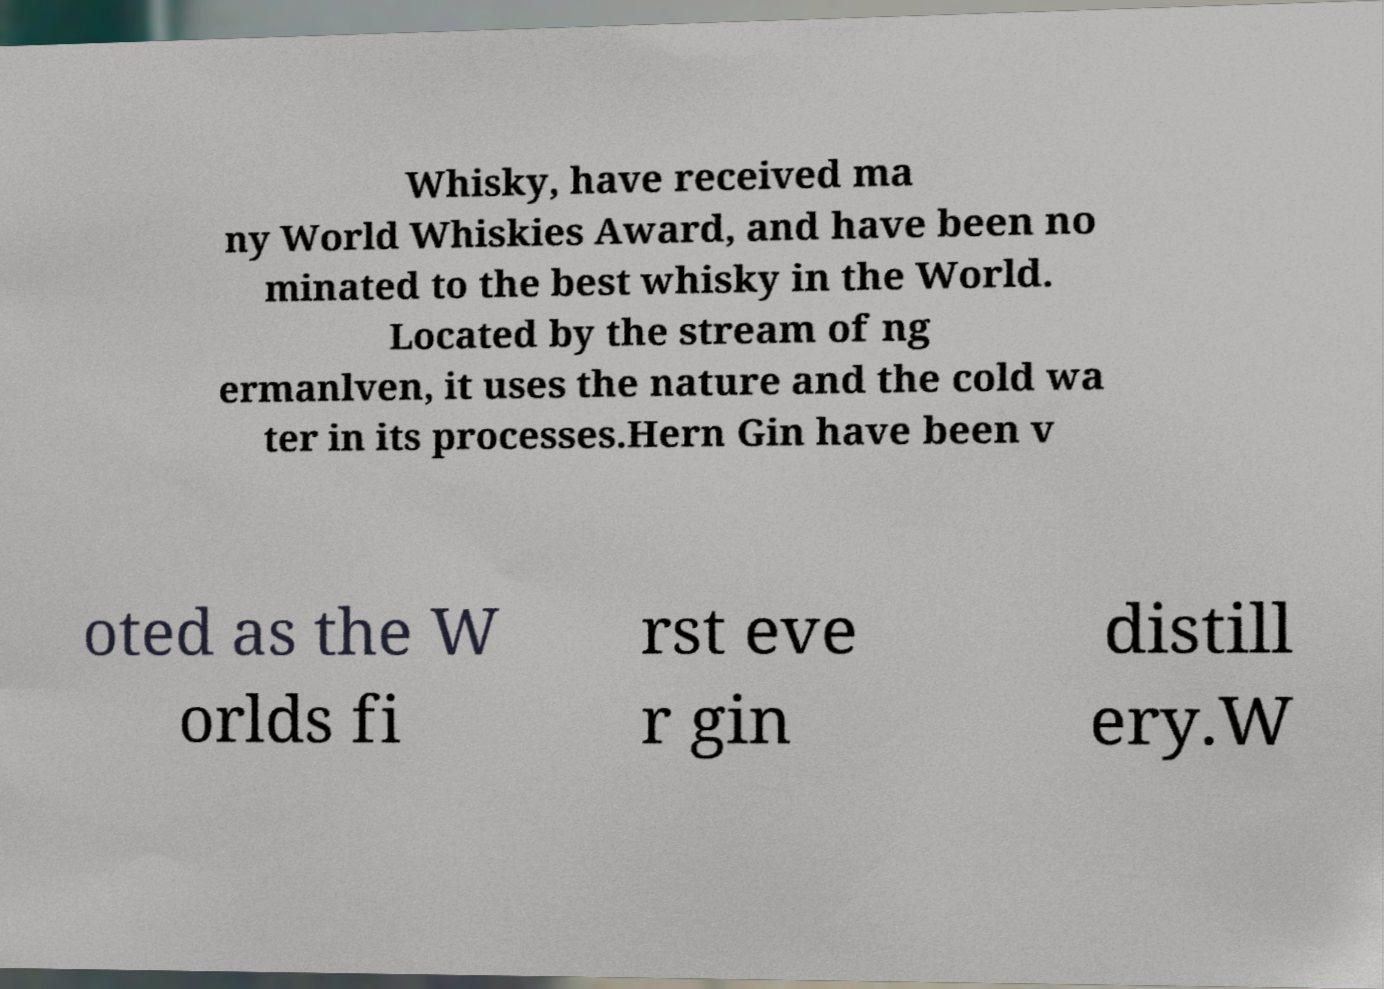Please read and relay the text visible in this image. What does it say? Whisky, have received ma ny World Whiskies Award, and have been no minated to the best whisky in the World. Located by the stream of ng ermanlven, it uses the nature and the cold wa ter in its processes.Hern Gin have been v oted as the W orlds fi rst eve r gin distill ery.W 